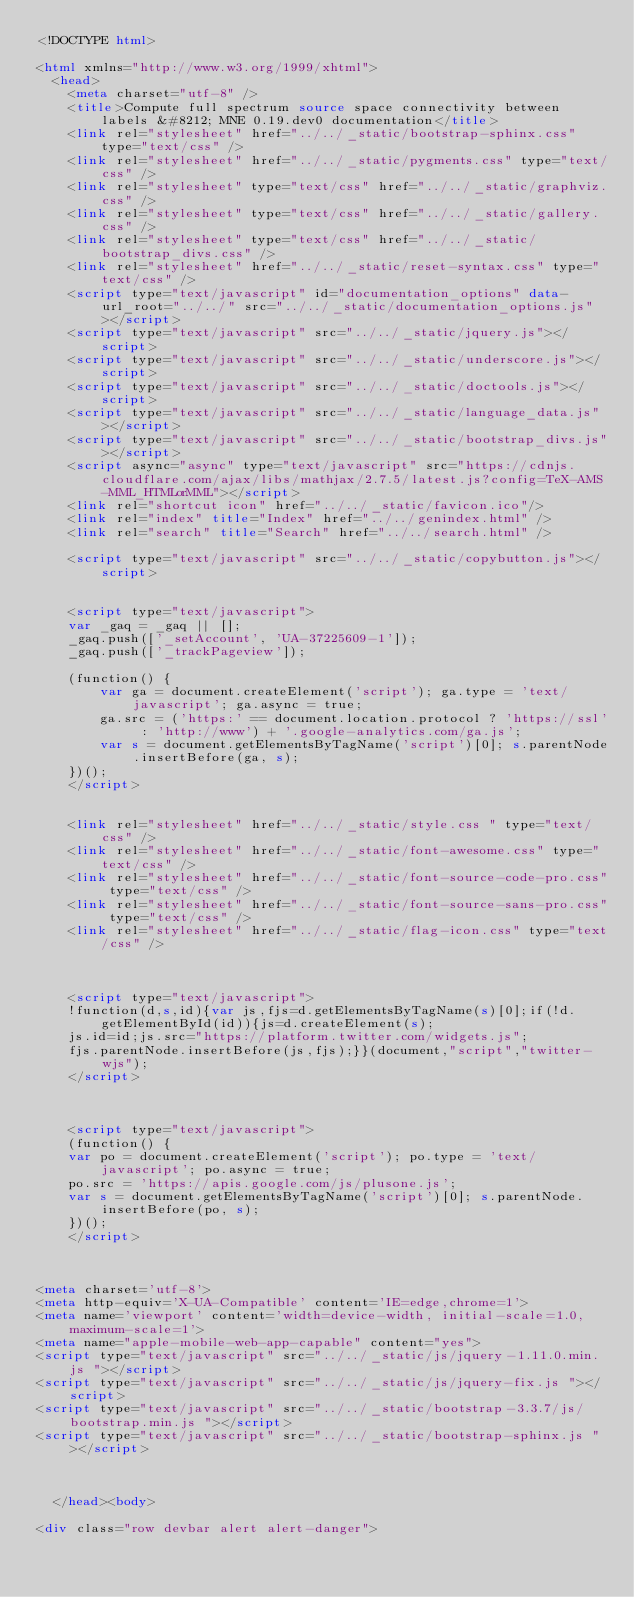<code> <loc_0><loc_0><loc_500><loc_500><_HTML_><!DOCTYPE html>

<html xmlns="http://www.w3.org/1999/xhtml">
  <head>
    <meta charset="utf-8" />
    <title>Compute full spectrum source space connectivity between labels &#8212; MNE 0.19.dev0 documentation</title>
    <link rel="stylesheet" href="../../_static/bootstrap-sphinx.css" type="text/css" />
    <link rel="stylesheet" href="../../_static/pygments.css" type="text/css" />
    <link rel="stylesheet" type="text/css" href="../../_static/graphviz.css" />
    <link rel="stylesheet" type="text/css" href="../../_static/gallery.css" />
    <link rel="stylesheet" type="text/css" href="../../_static/bootstrap_divs.css" />
    <link rel="stylesheet" href="../../_static/reset-syntax.css" type="text/css" />
    <script type="text/javascript" id="documentation_options" data-url_root="../../" src="../../_static/documentation_options.js"></script>
    <script type="text/javascript" src="../../_static/jquery.js"></script>
    <script type="text/javascript" src="../../_static/underscore.js"></script>
    <script type="text/javascript" src="../../_static/doctools.js"></script>
    <script type="text/javascript" src="../../_static/language_data.js"></script>
    <script type="text/javascript" src="../../_static/bootstrap_divs.js"></script>
    <script async="async" type="text/javascript" src="https://cdnjs.cloudflare.com/ajax/libs/mathjax/2.7.5/latest.js?config=TeX-AMS-MML_HTMLorMML"></script>
    <link rel="shortcut icon" href="../../_static/favicon.ico"/>
    <link rel="index" title="Index" href="../../genindex.html" />
    <link rel="search" title="Search" href="../../search.html" />

    <script type="text/javascript" src="../../_static/copybutton.js"></script>


    <script type="text/javascript">
    var _gaq = _gaq || [];
    _gaq.push(['_setAccount', 'UA-37225609-1']);
    _gaq.push(['_trackPageview']);

    (function() {
        var ga = document.createElement('script'); ga.type = 'text/javascript'; ga.async = true;
        ga.src = ('https:' == document.location.protocol ? 'https://ssl' : 'http://www') + '.google-analytics.com/ga.js';
        var s = document.getElementsByTagName('script')[0]; s.parentNode.insertBefore(ga, s);
    })();
    </script>


    <link rel="stylesheet" href="../../_static/style.css " type="text/css" />
    <link rel="stylesheet" href="../../_static/font-awesome.css" type="text/css" />
    <link rel="stylesheet" href="../../_static/font-source-code-pro.css" type="text/css" />
    <link rel="stylesheet" href="../../_static/font-source-sans-pro.css" type="text/css" />
    <link rel="stylesheet" href="../../_static/flag-icon.css" type="text/css" />



    <script type="text/javascript">
    !function(d,s,id){var js,fjs=d.getElementsByTagName(s)[0];if(!d.getElementById(id)){js=d.createElement(s);
    js.id=id;js.src="https://platform.twitter.com/widgets.js";
    fjs.parentNode.insertBefore(js,fjs);}}(document,"script","twitter-wjs");
    </script>



    <script type="text/javascript">
    (function() {
    var po = document.createElement('script'); po.type = 'text/javascript'; po.async = true;
    po.src = 'https://apis.google.com/js/plusone.js';
    var s = document.getElementsByTagName('script')[0]; s.parentNode.insertBefore(po, s);
    })();
    </script>



<meta charset='utf-8'>
<meta http-equiv='X-UA-Compatible' content='IE=edge,chrome=1'>
<meta name='viewport' content='width=device-width, initial-scale=1.0, maximum-scale=1'>
<meta name="apple-mobile-web-app-capable" content="yes">
<script type="text/javascript" src="../../_static/js/jquery-1.11.0.min.js "></script>
<script type="text/javascript" src="../../_static/js/jquery-fix.js "></script>
<script type="text/javascript" src="../../_static/bootstrap-3.3.7/js/bootstrap.min.js "></script>
<script type="text/javascript" src="../../_static/bootstrap-sphinx.js "></script>



  </head><body>

<div class="row devbar alert alert-danger"></code> 